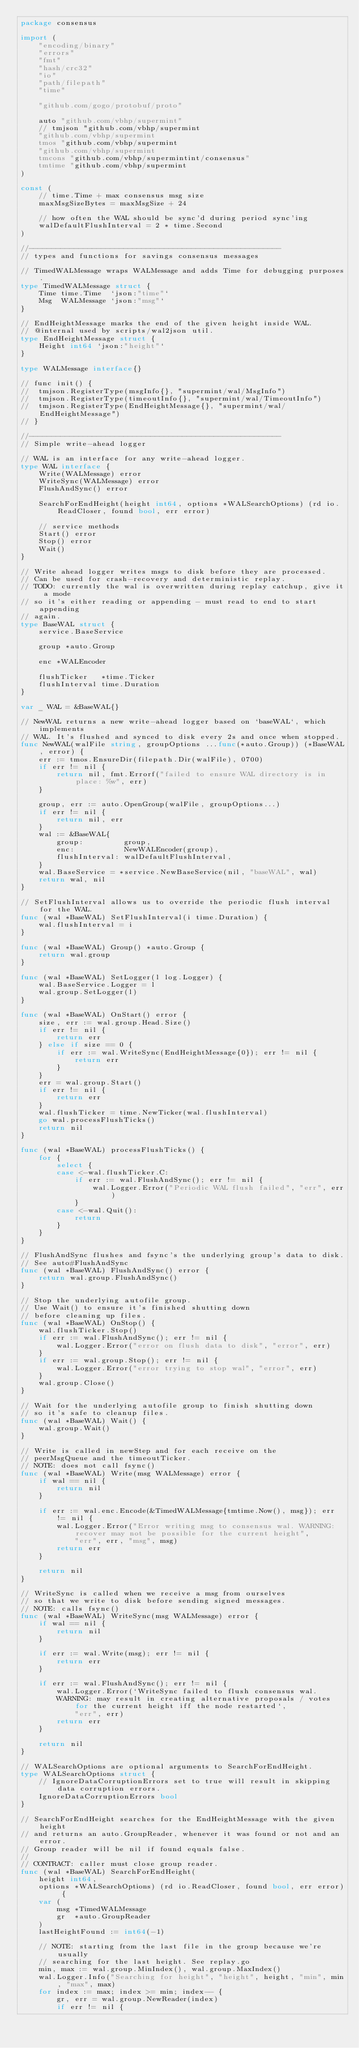<code> <loc_0><loc_0><loc_500><loc_500><_Go_>package consensus

import (
	"encoding/binary"
	"errors"
	"fmt"
	"hash/crc32"
	"io"
	"path/filepath"
	"time"

	"github.com/gogo/protobuf/proto"

	auto "github.com/vbhp/supermint"
	// tmjson "github.com/vbhp/supermint
	"github.com/vbhp/supermint
	tmos "github.com/vbhp/supermint
	"github.com/vbhp/supermint
	tmcons "github.com/vbhp/supermintint/consensus"
	tmtime "github.com/vbhp/supermint
)

const (
	// time.Time + max consensus msg size
	maxMsgSizeBytes = maxMsgSize + 24

	// how often the WAL should be sync'd during period sync'ing
	walDefaultFlushInterval = 2 * time.Second
)

//--------------------------------------------------------
// types and functions for savings consensus messages

// TimedWALMessage wraps WALMessage and adds Time for debugging purposes.
type TimedWALMessage struct {
	Time time.Time  `json:"time"`
	Msg  WALMessage `json:"msg"`
}

// EndHeightMessage marks the end of the given height inside WAL.
// @internal used by scripts/wal2json util.
type EndHeightMessage struct {
	Height int64 `json:"height"`
}

type WALMessage interface{}

// func init() {
// 	tmjson.RegisterType(msgInfo{}, "supermint/wal/MsgInfo")
// 	tmjson.RegisterType(timeoutInfo{}, "supermint/wal/TimeoutInfo")
// 	tmjson.RegisterType(EndHeightMessage{}, "supermint/wal/EndHeightMessage")
// }

//--------------------------------------------------------
// Simple write-ahead logger

// WAL is an interface for any write-ahead logger.
type WAL interface {
	Write(WALMessage) error
	WriteSync(WALMessage) error
	FlushAndSync() error

	SearchForEndHeight(height int64, options *WALSearchOptions) (rd io.ReadCloser, found bool, err error)

	// service methods
	Start() error
	Stop() error
	Wait()
}

// Write ahead logger writes msgs to disk before they are processed.
// Can be used for crash-recovery and deterministic replay.
// TODO: currently the wal is overwritten during replay catchup, give it a mode
// so it's either reading or appending - must read to end to start appending
// again.
type BaseWAL struct {
	service.BaseService

	group *auto.Group

	enc *WALEncoder

	flushTicker   *time.Ticker
	flushInterval time.Duration
}

var _ WAL = &BaseWAL{}

// NewWAL returns a new write-ahead logger based on `baseWAL`, which implements
// WAL. It's flushed and synced to disk every 2s and once when stopped.
func NewWAL(walFile string, groupOptions ...func(*auto.Group)) (*BaseWAL, error) {
	err := tmos.EnsureDir(filepath.Dir(walFile), 0700)
	if err != nil {
		return nil, fmt.Errorf("failed to ensure WAL directory is in place: %w", err)
	}

	group, err := auto.OpenGroup(walFile, groupOptions...)
	if err != nil {
		return nil, err
	}
	wal := &BaseWAL{
		group:         group,
		enc:           NewWALEncoder(group),
		flushInterval: walDefaultFlushInterval,
	}
	wal.BaseService = *service.NewBaseService(nil, "baseWAL", wal)
	return wal, nil
}

// SetFlushInterval allows us to override the periodic flush interval for the WAL.
func (wal *BaseWAL) SetFlushInterval(i time.Duration) {
	wal.flushInterval = i
}

func (wal *BaseWAL) Group() *auto.Group {
	return wal.group
}

func (wal *BaseWAL) SetLogger(l log.Logger) {
	wal.BaseService.Logger = l
	wal.group.SetLogger(l)
}

func (wal *BaseWAL) OnStart() error {
	size, err := wal.group.Head.Size()
	if err != nil {
		return err
	} else if size == 0 {
		if err := wal.WriteSync(EndHeightMessage{0}); err != nil {
			return err
		}
	}
	err = wal.group.Start()
	if err != nil {
		return err
	}
	wal.flushTicker = time.NewTicker(wal.flushInterval)
	go wal.processFlushTicks()
	return nil
}

func (wal *BaseWAL) processFlushTicks() {
	for {
		select {
		case <-wal.flushTicker.C:
			if err := wal.FlushAndSync(); err != nil {
				wal.Logger.Error("Periodic WAL flush failed", "err", err)
			}
		case <-wal.Quit():
			return
		}
	}
}

// FlushAndSync flushes and fsync's the underlying group's data to disk.
// See auto#FlushAndSync
func (wal *BaseWAL) FlushAndSync() error {
	return wal.group.FlushAndSync()
}

// Stop the underlying autofile group.
// Use Wait() to ensure it's finished shutting down
// before cleaning up files.
func (wal *BaseWAL) OnStop() {
	wal.flushTicker.Stop()
	if err := wal.FlushAndSync(); err != nil {
		wal.Logger.Error("error on flush data to disk", "error", err)
	}
	if err := wal.group.Stop(); err != nil {
		wal.Logger.Error("error trying to stop wal", "error", err)
	}
	wal.group.Close()
}

// Wait for the underlying autofile group to finish shutting down
// so it's safe to cleanup files.
func (wal *BaseWAL) Wait() {
	wal.group.Wait()
}

// Write is called in newStep and for each receive on the
// peerMsgQueue and the timeoutTicker.
// NOTE: does not call fsync()
func (wal *BaseWAL) Write(msg WALMessage) error {
	if wal == nil {
		return nil
	}

	if err := wal.enc.Encode(&TimedWALMessage{tmtime.Now(), msg}); err != nil {
		wal.Logger.Error("Error writing msg to consensus wal. WARNING: recover may not be possible for the current height",
			"err", err, "msg", msg)
		return err
	}

	return nil
}

// WriteSync is called when we receive a msg from ourselves
// so that we write to disk before sending signed messages.
// NOTE: calls fsync()
func (wal *BaseWAL) WriteSync(msg WALMessage) error {
	if wal == nil {
		return nil
	}

	if err := wal.Write(msg); err != nil {
		return err
	}

	if err := wal.FlushAndSync(); err != nil {
		wal.Logger.Error(`WriteSync failed to flush consensus wal. 
		WARNING: may result in creating alternative proposals / votes for the current height iff the node restarted`,
			"err", err)
		return err
	}

	return nil
}

// WALSearchOptions are optional arguments to SearchForEndHeight.
type WALSearchOptions struct {
	// IgnoreDataCorruptionErrors set to true will result in skipping data corruption errors.
	IgnoreDataCorruptionErrors bool
}

// SearchForEndHeight searches for the EndHeightMessage with the given height
// and returns an auto.GroupReader, whenever it was found or not and an error.
// Group reader will be nil if found equals false.
//
// CONTRACT: caller must close group reader.
func (wal *BaseWAL) SearchForEndHeight(
	height int64,
	options *WALSearchOptions) (rd io.ReadCloser, found bool, err error) {
	var (
		msg *TimedWALMessage
		gr  *auto.GroupReader
	)
	lastHeightFound := int64(-1)

	// NOTE: starting from the last file in the group because we're usually
	// searching for the last height. See replay.go
	min, max := wal.group.MinIndex(), wal.group.MaxIndex()
	wal.Logger.Info("Searching for height", "height", height, "min", min, "max", max)
	for index := max; index >= min; index-- {
		gr, err = wal.group.NewReader(index)
		if err != nil {</code> 